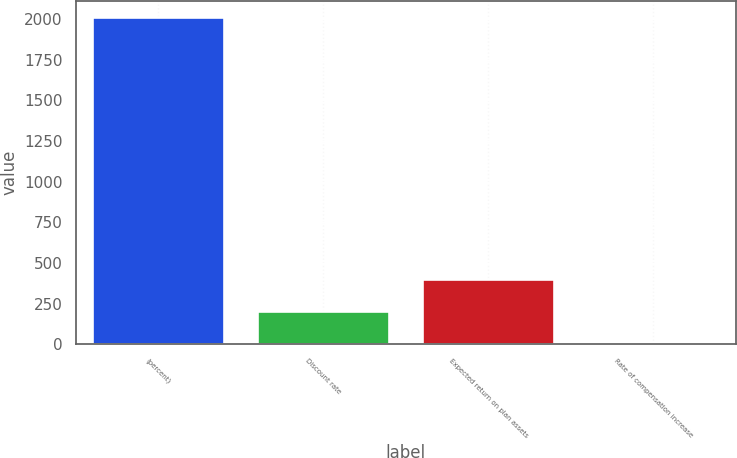Convert chart. <chart><loc_0><loc_0><loc_500><loc_500><bar_chart><fcel>(percent)<fcel>Discount rate<fcel>Expected return on plan assets<fcel>Rate of compensation increase<nl><fcel>2014<fcel>203.89<fcel>405.01<fcel>2.77<nl></chart> 